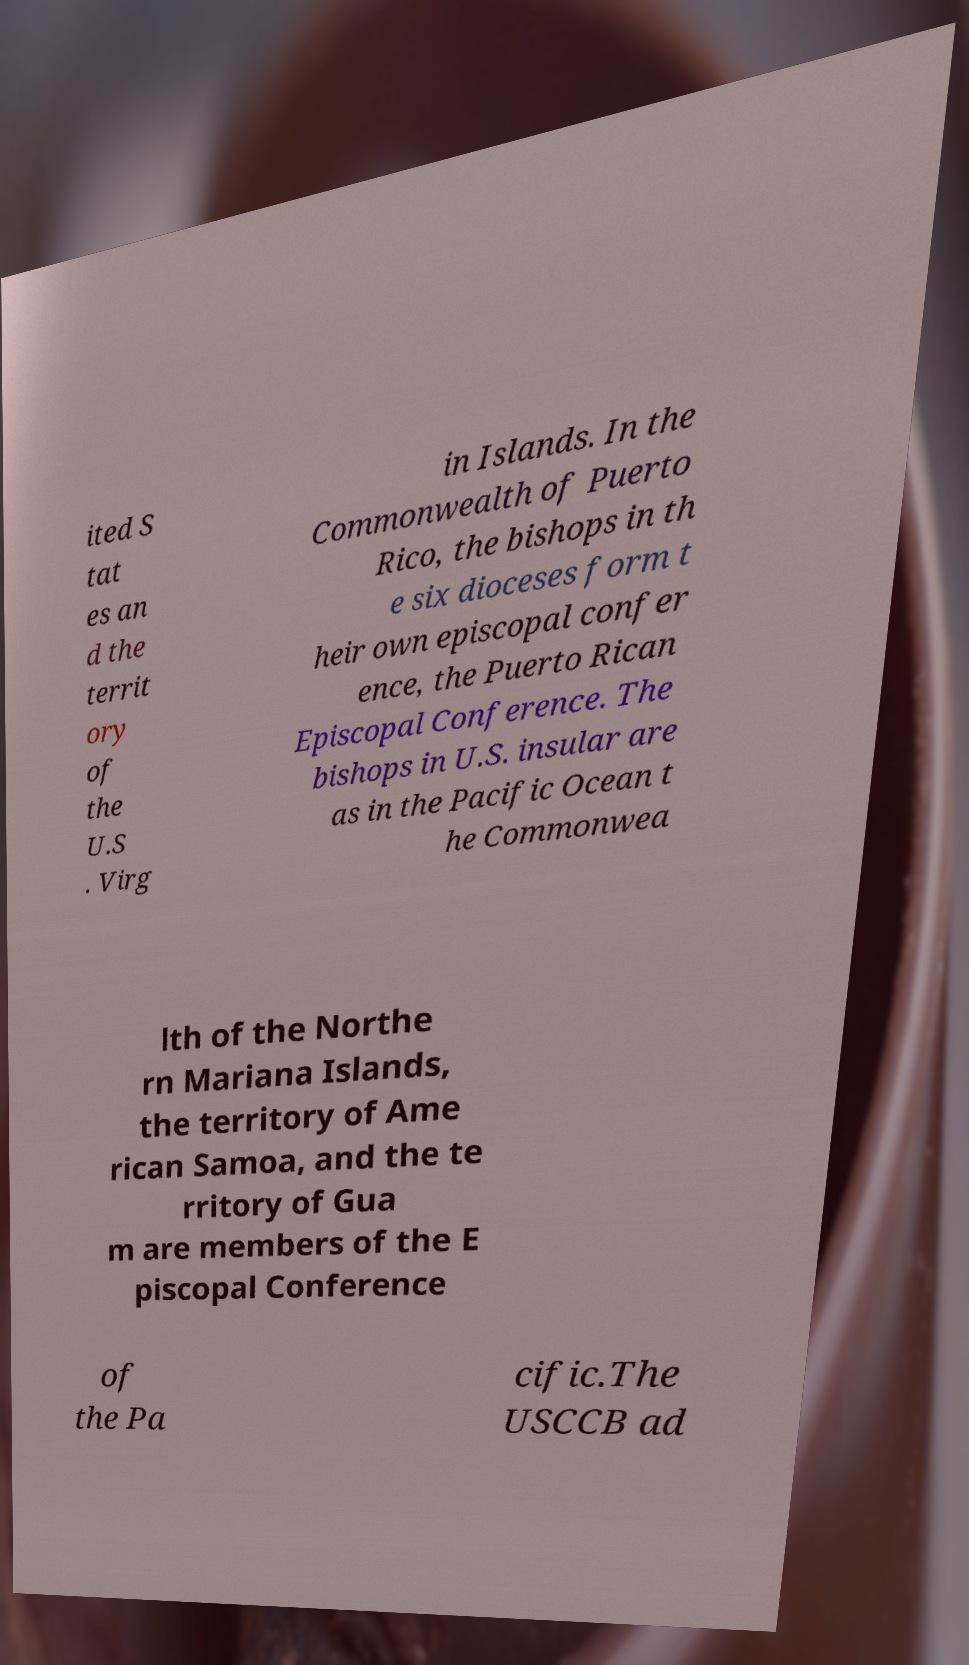Please identify and transcribe the text found in this image. ited S tat es an d the territ ory of the U.S . Virg in Islands. In the Commonwealth of Puerto Rico, the bishops in th e six dioceses form t heir own episcopal confer ence, the Puerto Rican Episcopal Conference. The bishops in U.S. insular are as in the Pacific Ocean t he Commonwea lth of the Northe rn Mariana Islands, the territory of Ame rican Samoa, and the te rritory of Gua m are members of the E piscopal Conference of the Pa cific.The USCCB ad 